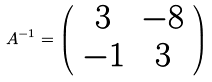Convert formula to latex. <formula><loc_0><loc_0><loc_500><loc_500>A ^ { - 1 } = \left ( \begin{array} { c c } 3 & - 8 \\ - 1 & 3 \\ \end{array} \right )</formula> 